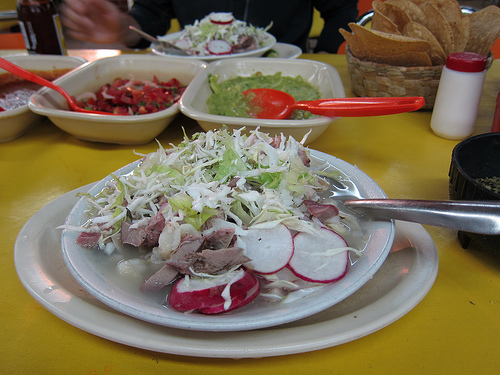<image>
Can you confirm if the shells is to the right of the spoon? No. The shells is not to the right of the spoon. The horizontal positioning shows a different relationship. 